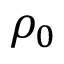Convert formula to latex. <formula><loc_0><loc_0><loc_500><loc_500>\rho _ { 0 }</formula> 